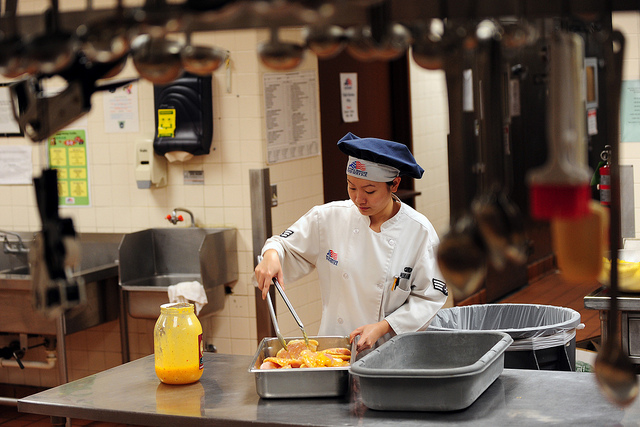Imagine this kitchen is in a spaceship. How might the chef's actions be different? In a spaceship, the chef's actions would be significantly influenced by the microgravity environment. Cooking in space often involves using specially designed equipment to prevent ingredients from floating away. The chef might secure food items and utensils with Velcro or magnets. Furthermore, liquid ingredients would need to be dispensed in controlled amounts, possibly through tubes, to avoid spills. Waste management and maintaining cleanliness would be critical, requiring the use of sealed containers and thorough procedures to prevent contamination in the enclosed space of the spacecraft. 